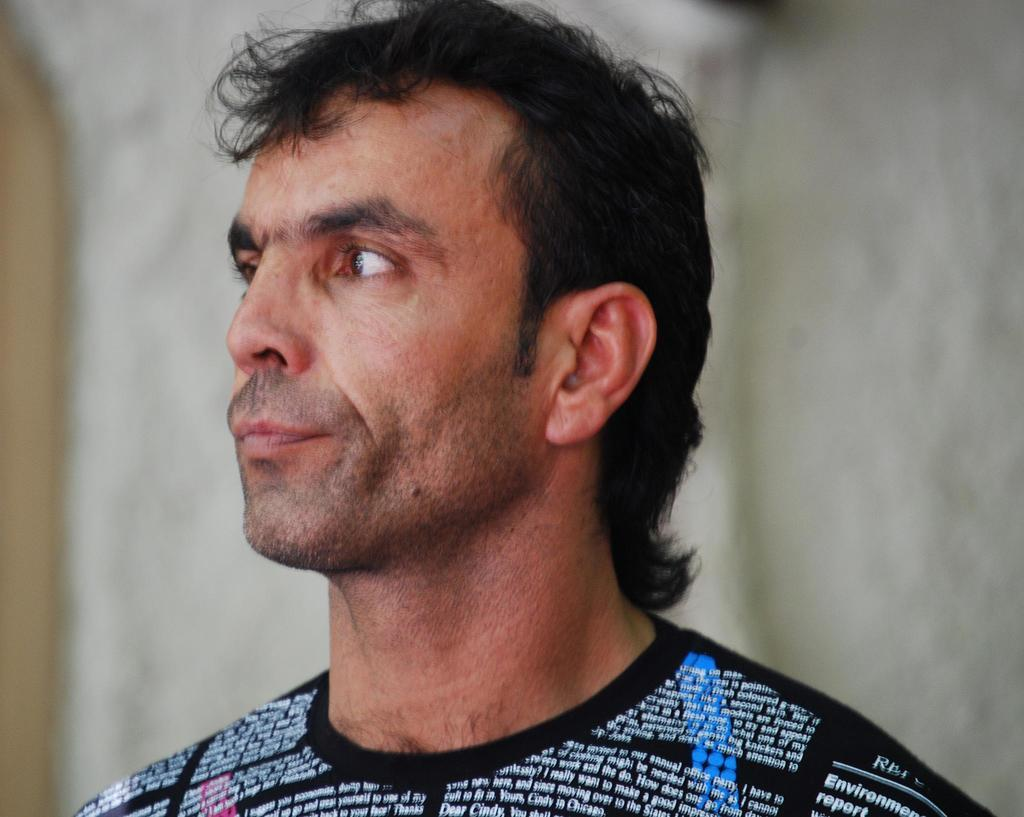Who or what is the main subject of the image? There is a person in the image. What is the person wearing in the image? The person is wearing a black T-shirt. Are there any specific details about the T-shirt? Yes, there is writing on the T-shirt. What can be seen in the background of the image? There is a wall in the background of the image. What type of bird is sitting on the person's shoulder in the image? There is no bird present in the image. What kind of oatmeal is being served on the table in the image? There is no table or oatmeal present in the image. 